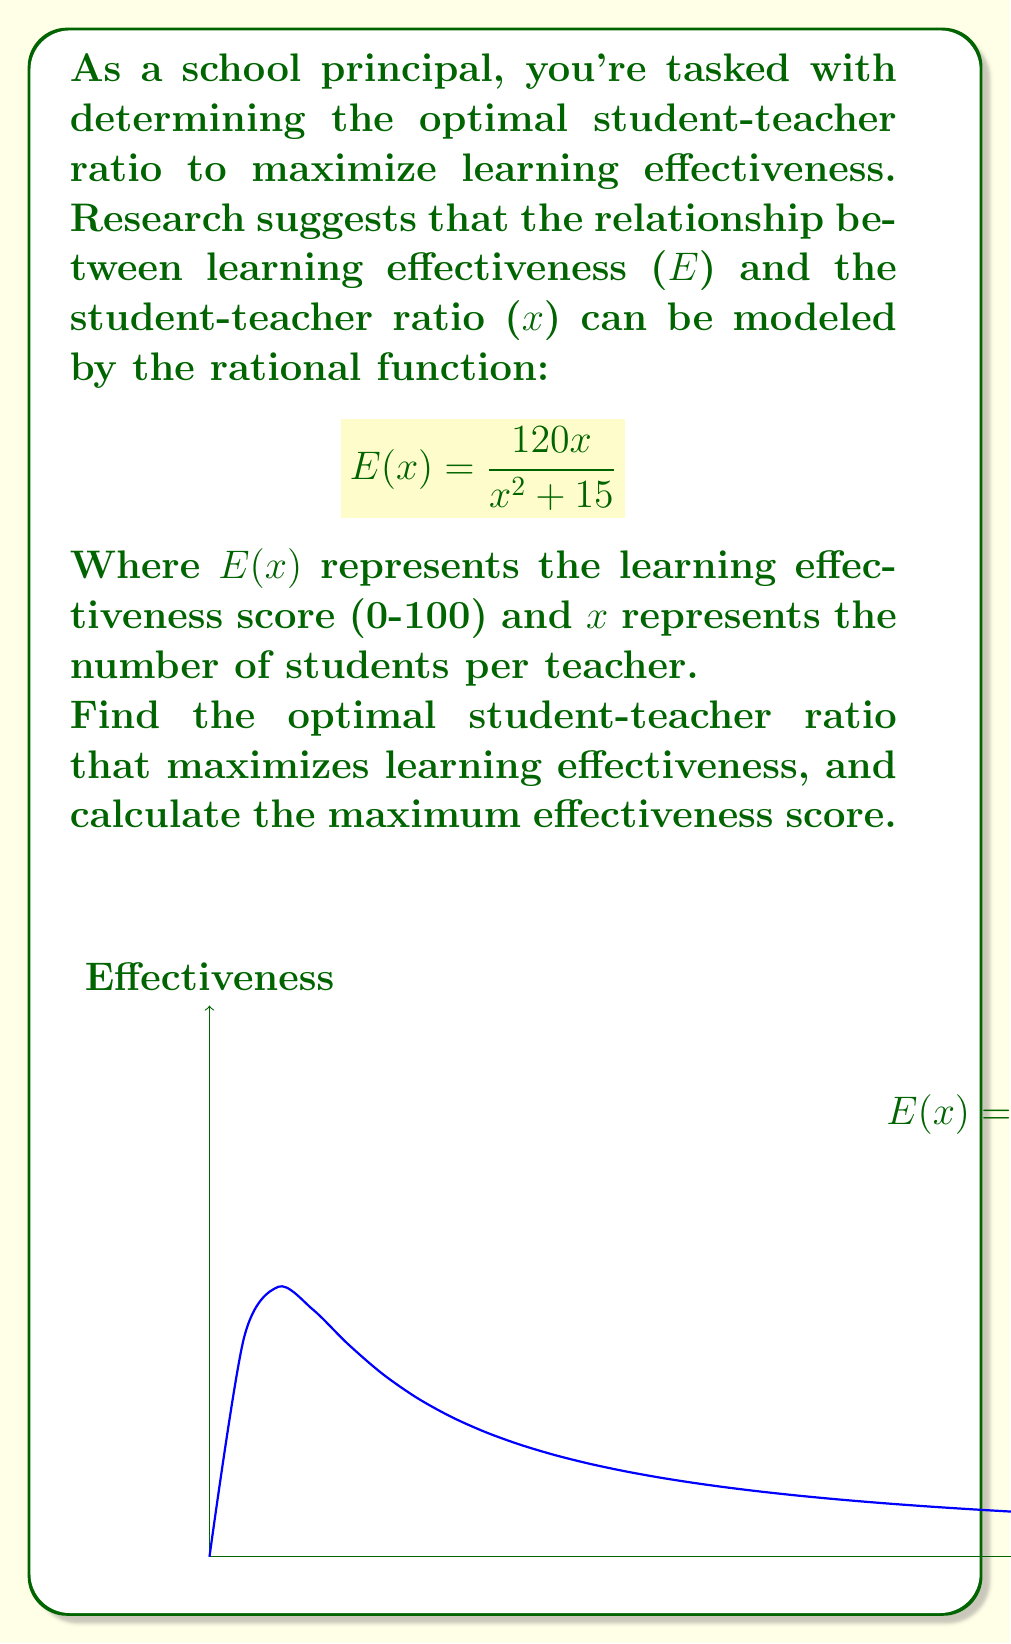Give your solution to this math problem. To find the optimal student-teacher ratio, we need to find the maximum of the function $E(x)$. We can do this by following these steps:

1) First, let's find the derivative of $E(x)$ using the quotient rule:

   $$E'(x) = \frac{(x^2 + 15)(120) - 120x(2x)}{(x^2 + 15)^2}$$

2) Simplify the numerator:

   $$E'(x) = \frac{120x^2 + 1800 - 240x^2}{(x^2 + 15)^2} = \frac{1800 - 120x^2}{(x^2 + 15)^2}$$

3) To find the maximum, set $E'(x) = 0$ and solve for $x$:

   $$\frac{1800 - 120x^2}{(x^2 + 15)^2} = 0$$

4) The denominator is always positive, so we only need to solve:

   $$1800 - 120x^2 = 0$$
   $$120x^2 = 1800$$
   $$x^2 = 15$$
   $$x = \sqrt{15} \approx 3.87$$

5) The second derivative is negative at this point, confirming it's a maximum.

6) To find the maximum effectiveness score, plug $x = \sqrt{15}$ into the original function:

   $$E(\sqrt{15}) = \frac{120\sqrt{15}}{(\sqrt{15})^2 + 15} = \frac{120\sqrt{15}}{30} = 4\sqrt{15} \approx 15.49$$

Therefore, the optimal student-teacher ratio is $\sqrt{15}$ students per teacher (approximately 3.87:1), and the maximum effectiveness score is $4\sqrt{15}$ (approximately 15.49 out of 100).
Answer: Optimal ratio: $\sqrt{15}:1$; Maximum score: $4\sqrt{15}$ 